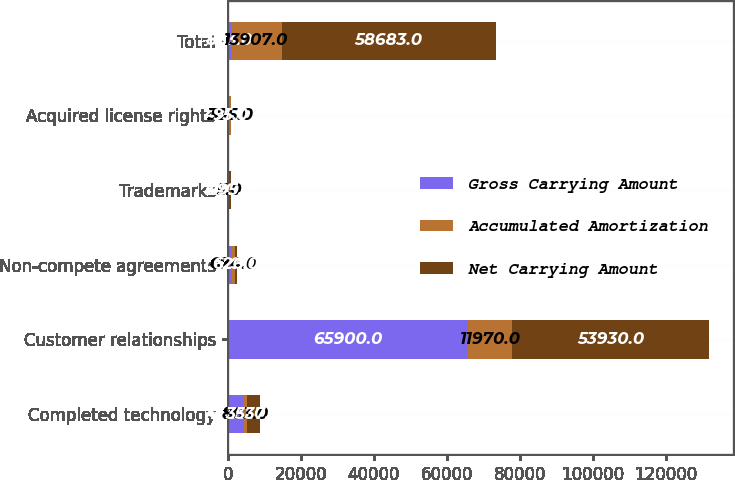<chart> <loc_0><loc_0><loc_500><loc_500><stacked_bar_chart><ecel><fcel>Completed technology<fcel>Customer relationships<fcel>Non-compete agreements<fcel>Trademarks<fcel>Acquired license rights<fcel>Total<nl><fcel>Gross Carrying Amount<fcel>4400<fcel>65900<fcel>1300<fcel>500<fcel>490<fcel>863<nl><fcel>Accumulated Amortization<fcel>863<fcel>11970<fcel>674<fcel>5<fcel>395<fcel>13907<nl><fcel>Net Carrying Amount<fcel>3537<fcel>53930<fcel>626<fcel>495<fcel>95<fcel>58683<nl></chart> 